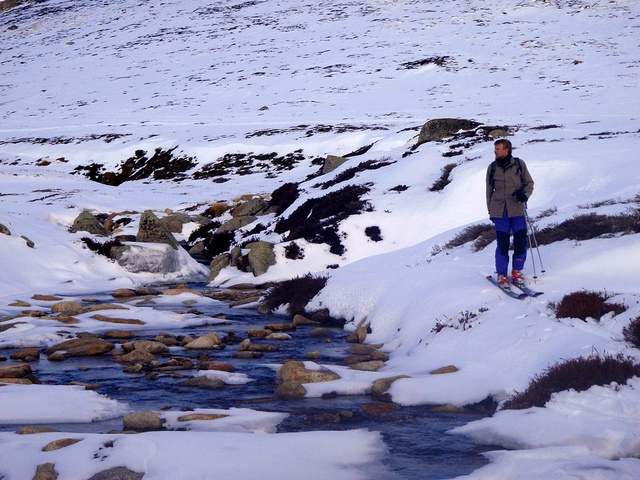Describe the objects in this image and their specific colors. I can see people in lavender, black, navy, and purple tones and skis in lavender, navy, blue, purple, and darkblue tones in this image. 